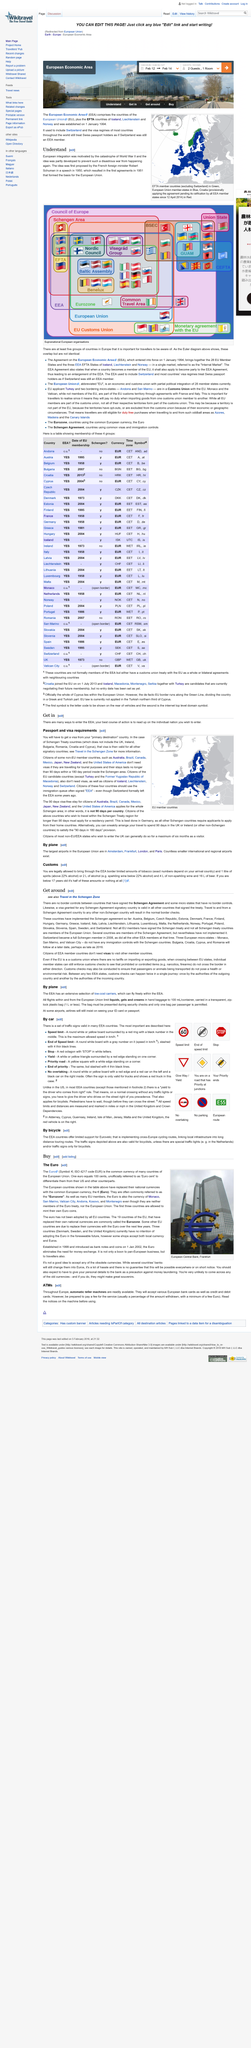Specify some key components in this picture. Has Italy implemented the Schengen agreement? The answer is yes. Yes, Poland has fully implemented the Schengen agreement. Switzerland is not a member of the EEA, as it withdrew from the organization several years ago. Denmark has fully implemented the Schengen agreement. Some countries, including Australia, Brazil, and Canada, are able to travel in the EEA without a visa, as per the current regulations. 